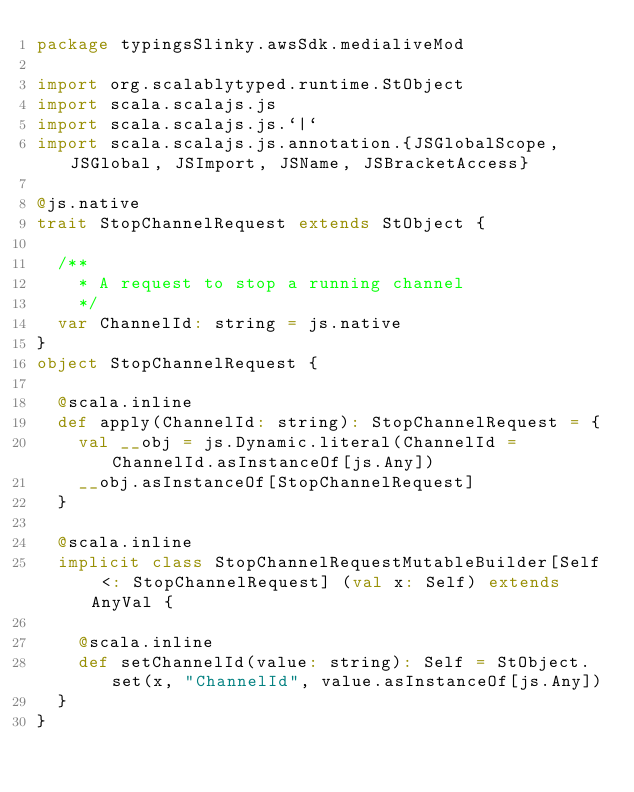Convert code to text. <code><loc_0><loc_0><loc_500><loc_500><_Scala_>package typingsSlinky.awsSdk.medialiveMod

import org.scalablytyped.runtime.StObject
import scala.scalajs.js
import scala.scalajs.js.`|`
import scala.scalajs.js.annotation.{JSGlobalScope, JSGlobal, JSImport, JSName, JSBracketAccess}

@js.native
trait StopChannelRequest extends StObject {
  
  /**
    * A request to stop a running channel
    */
  var ChannelId: string = js.native
}
object StopChannelRequest {
  
  @scala.inline
  def apply(ChannelId: string): StopChannelRequest = {
    val __obj = js.Dynamic.literal(ChannelId = ChannelId.asInstanceOf[js.Any])
    __obj.asInstanceOf[StopChannelRequest]
  }
  
  @scala.inline
  implicit class StopChannelRequestMutableBuilder[Self <: StopChannelRequest] (val x: Self) extends AnyVal {
    
    @scala.inline
    def setChannelId(value: string): Self = StObject.set(x, "ChannelId", value.asInstanceOf[js.Any])
  }
}
</code> 